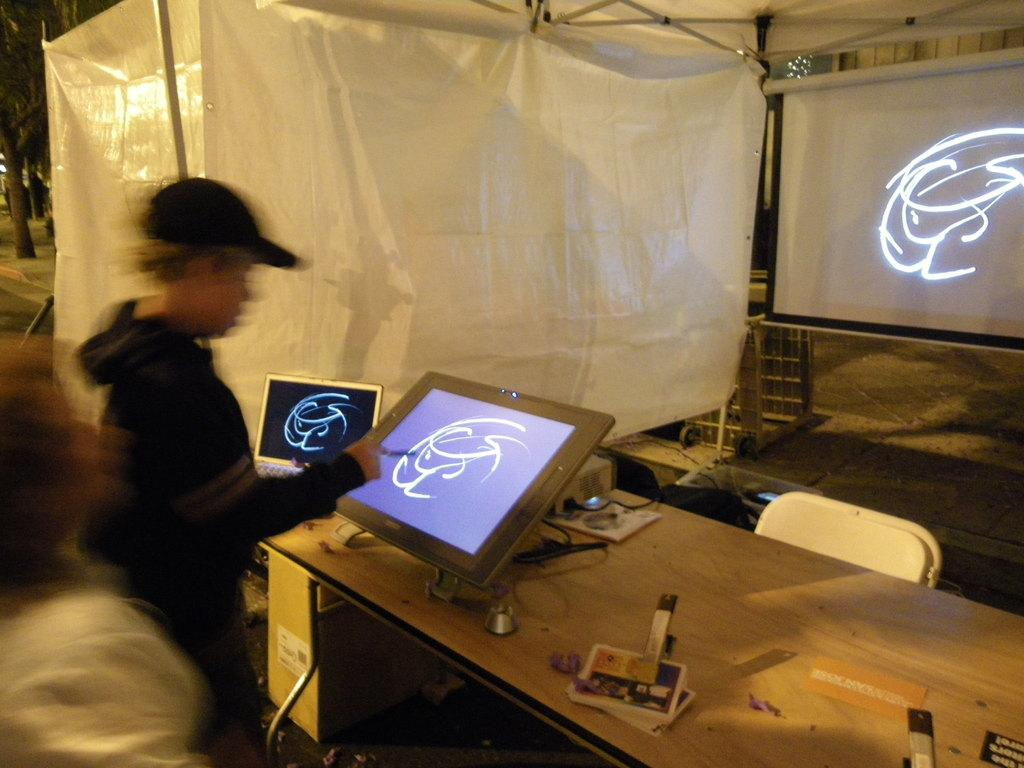What is the main subject of the image? There is a guy in the image. What is the guy doing in the image? The guy is playing on an electronic gadget. Where is the electronic gadget located? The electronic gadget is on a table. What can be seen in the background of the image? There is a screen projector in the background of the image. What is to the left of the screen projector? There is a white curtain to the left of the screen projector. How much debt does the guy owe in the image? There is no information about the guy's debt in the image. What is the guy's level of fear while playing on the electronic gadget? There is no indication of the guy's fear in the image. 